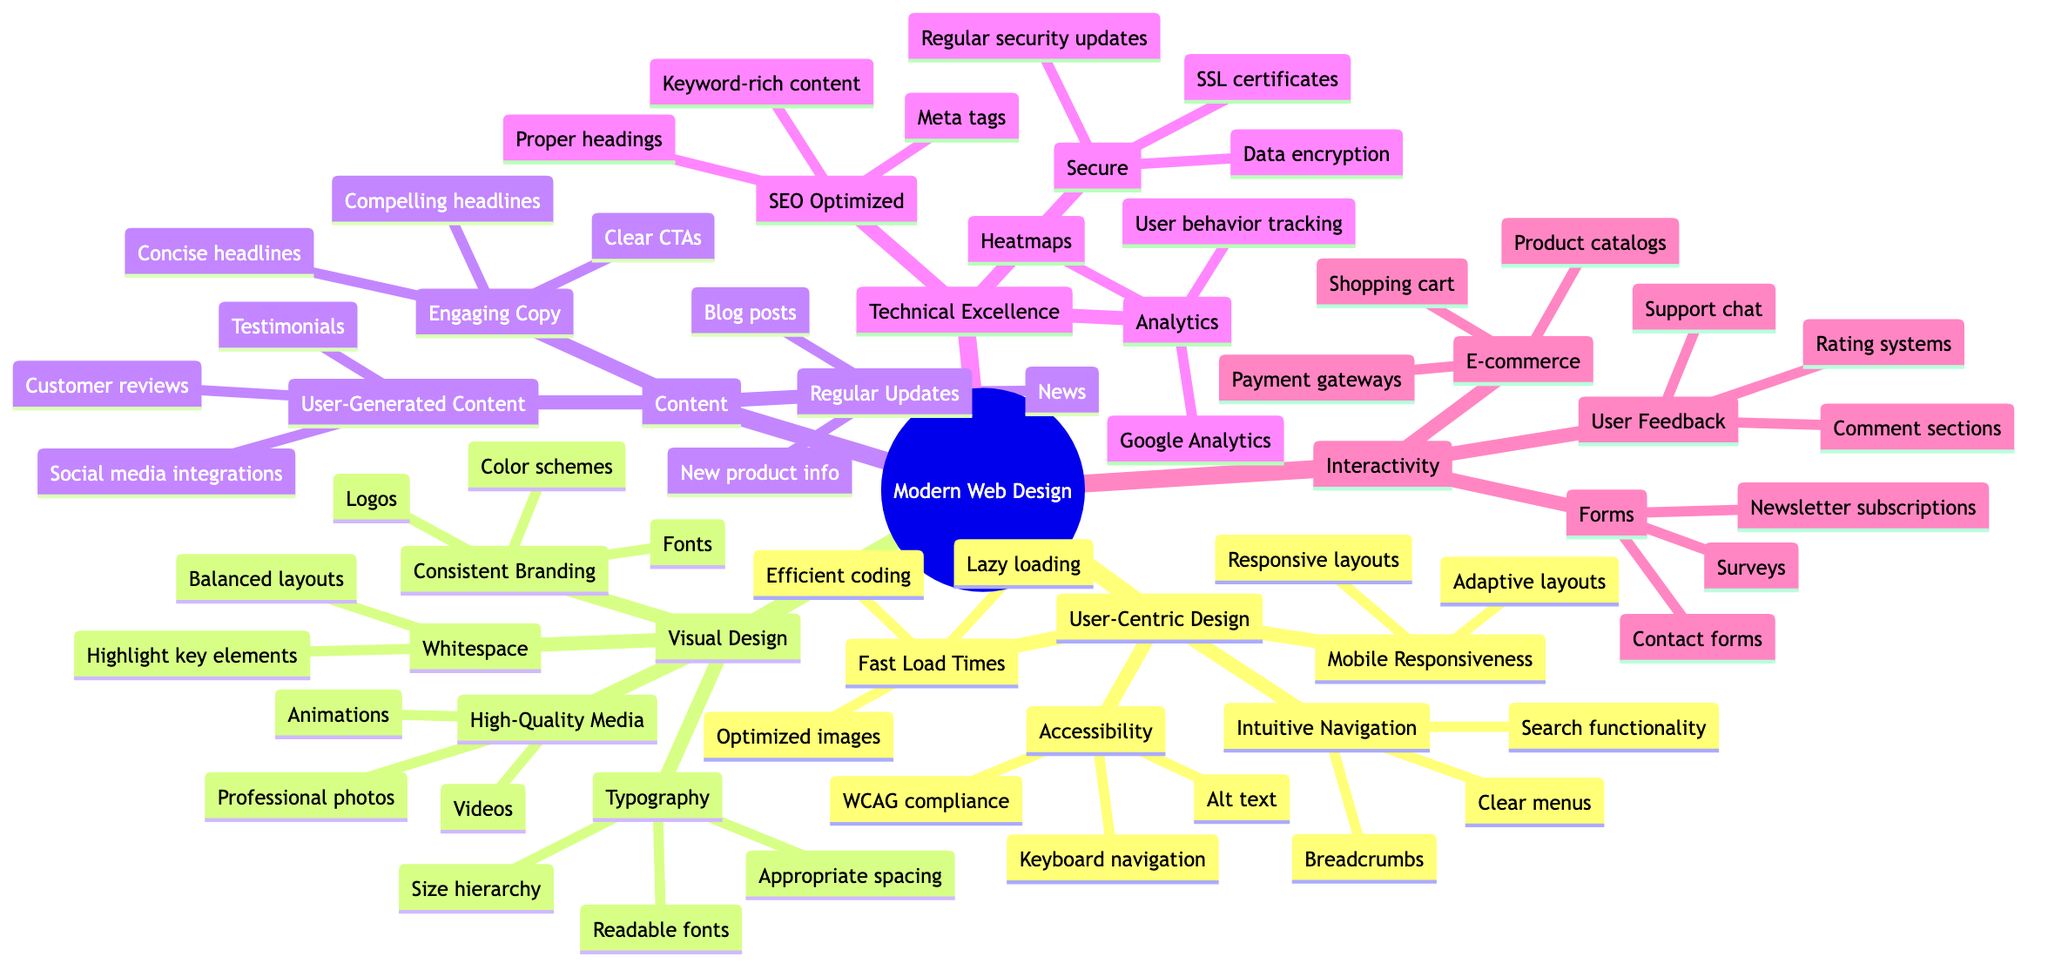What are the four main categories in the Mind Map? The Mind Map outlines four main categories: User-Centric Design, Visual Design, Content, Technical Excellence, and Interactivity. These categories can be identified as the first-level nodes in the diagram.
Answer: User-Centric Design, Visual Design, Content, Technical Excellence, Interactivity How many subcategories are under Visual Design? The Visual Design category includes four subcategories: Consistent Branding, High-Quality Media, Typography, and Whitespace. By counting these subcategories, we determine the total number of nodes under this category.
Answer: 4 What is one aspect of User-Centric Design? From the User-Centric Design category, one aspect mentioned is Intuitive Navigation. This represents one of the key elements essential for a user-friendly web design.
Answer: Intuitive Navigation Which category contains customer reviews? Customer reviews are located under the User-Generated Content subcategory, which is part of the Content category. By tracing the path from the Customer reviews node, we find its parent categories.
Answer: Content What is the second node under Technical Excellence? The second node under Technical Excellence is Secure. This can be found by listing the nodes sequentially under the Technical Excellence category.
Answer: Secure How many components are listed under Interactivity? The Interactivity category consists of three main components: Forms, E-commerce, and User Feedback. By tallying these components, we can identify the total count.
Answer: 3 Identify one element that affects Mobile Responsiveness. Under Mobile Responsiveness, Adaptive layouts are one of the elements affecting how a website responds to different device sizes. This can be identified as a sub-node under the main category.
Answer: Adaptive layouts What aspect of visual design highlights important elements? Whitespace focuses on highlighting key elements by using balanced layouts to provide space between elements, making it a notable aspect of visual design. This is found as a subcategory in the Visual Design section.
Answer: Whitespace How is the website optimized for SEO? The SEO Optimized subcategory lists elements such as Meta tags, keyword-rich content, and proper headings, collectively contributing to website optimization for search engines. This understanding grows from analyzing the specifics under Technical Excellence.
Answer: Meta tags, keyword-rich content, proper headings 